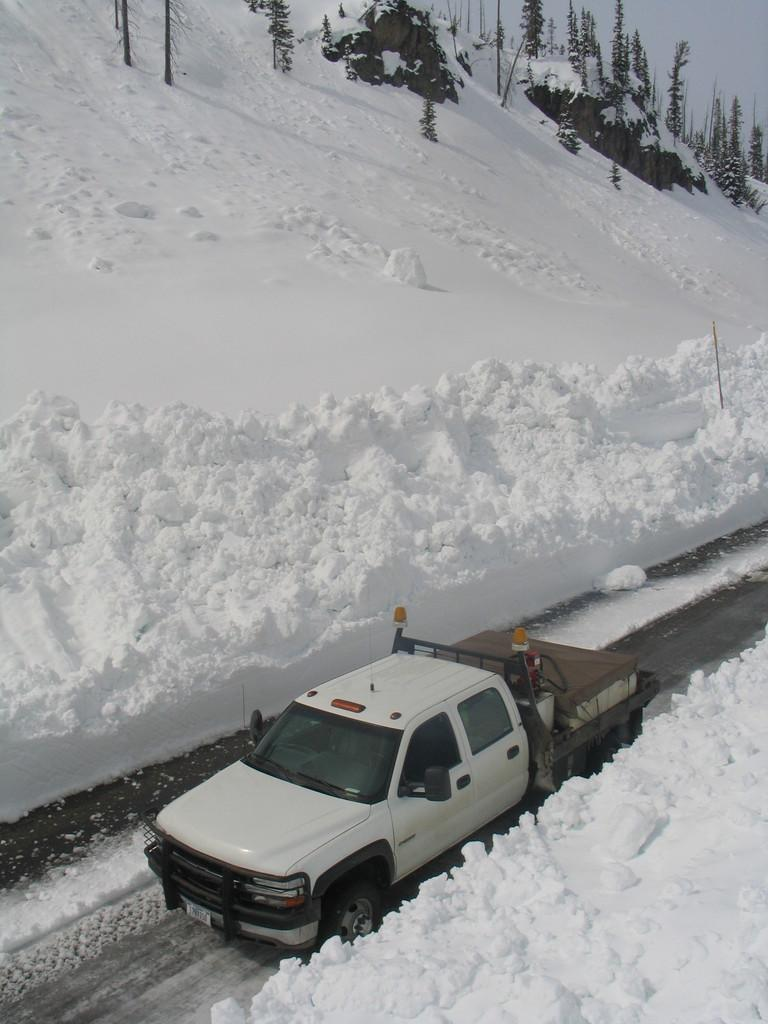What is the main subject of the image? There is a vehicle in the image. Where is the vehicle located? The vehicle is on the road. What can be found inside the truck? There are objects in the truck. What is the weather like in the image? Snow is visible on either side of the road suggests a cold or wintery weather. What can be seen in the background of the image? There are trees, a pole, rocks, and the sky visible in the background of the image. How many ladybugs can be seen crawling on the vehicle in the image? There are no ladybugs present in the image. What type of cattle can be seen grazing in the background of the image? There are no cattle present in the image. 